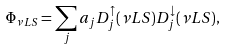Convert formula to latex. <formula><loc_0><loc_0><loc_500><loc_500>\Phi _ { \nu L S } = \sum _ { j } a _ { j } D _ { j } ^ { \uparrow } ( \nu L S ) D _ { j } ^ { \downarrow } ( \nu L S ) ,</formula> 